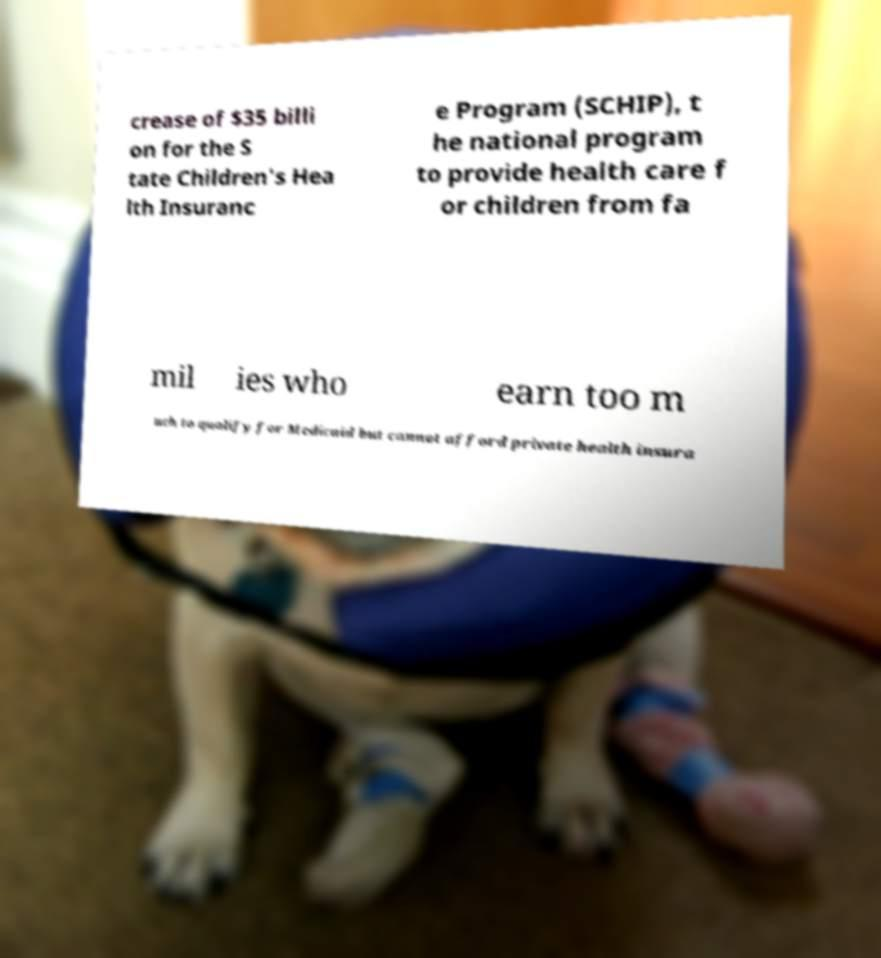What messages or text are displayed in this image? I need them in a readable, typed format. crease of $35 billi on for the S tate Children's Hea lth Insuranc e Program (SCHIP), t he national program to provide health care f or children from fa mil ies who earn too m uch to qualify for Medicaid but cannot afford private health insura 